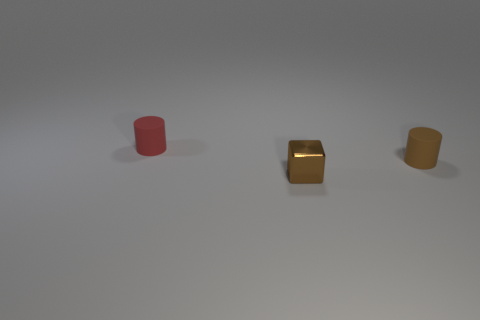Add 2 small red matte cylinders. How many objects exist? 5 Subtract all cylinders. How many objects are left? 1 Add 2 tiny shiny cubes. How many tiny shiny cubes are left? 3 Add 2 red rubber cylinders. How many red rubber cylinders exist? 3 Subtract 0 purple cylinders. How many objects are left? 3 Subtract all big cyan metallic cubes. Subtract all red rubber cylinders. How many objects are left? 2 